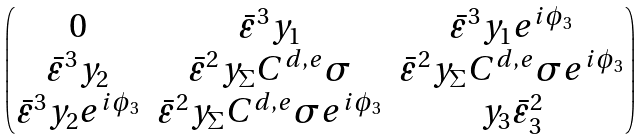<formula> <loc_0><loc_0><loc_500><loc_500>\begin{pmatrix} 0 & \bar { \varepsilon } ^ { 3 } y _ { 1 } & \bar { \varepsilon } ^ { 3 } y _ { 1 } e ^ { i \phi _ { 3 } } \\ \bar { \varepsilon } ^ { 3 } y _ { 2 } & \bar { \varepsilon } ^ { 2 } y _ { \Sigma } C ^ { d , e } \sigma & \bar { \varepsilon } ^ { 2 } y _ { \Sigma } C ^ { d , e } \sigma e ^ { i \phi _ { 3 } } \\ \bar { \varepsilon } ^ { 3 } y _ { 2 } e ^ { i \phi _ { 3 } } & \bar { \varepsilon } ^ { 2 } y _ { \Sigma } C ^ { d , e } \sigma e ^ { i \phi _ { 3 } } & y _ { 3 } \bar { \varepsilon } _ { 3 } ^ { 2 } \end{pmatrix}</formula> 